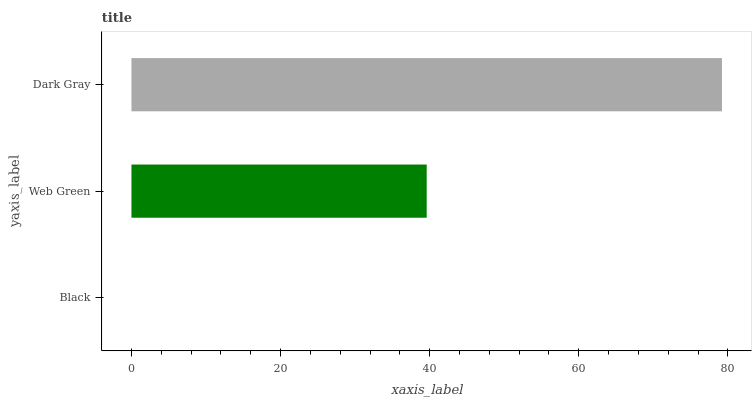Is Black the minimum?
Answer yes or no. Yes. Is Dark Gray the maximum?
Answer yes or no. Yes. Is Web Green the minimum?
Answer yes or no. No. Is Web Green the maximum?
Answer yes or no. No. Is Web Green greater than Black?
Answer yes or no. Yes. Is Black less than Web Green?
Answer yes or no. Yes. Is Black greater than Web Green?
Answer yes or no. No. Is Web Green less than Black?
Answer yes or no. No. Is Web Green the high median?
Answer yes or no. Yes. Is Web Green the low median?
Answer yes or no. Yes. Is Black the high median?
Answer yes or no. No. Is Dark Gray the low median?
Answer yes or no. No. 